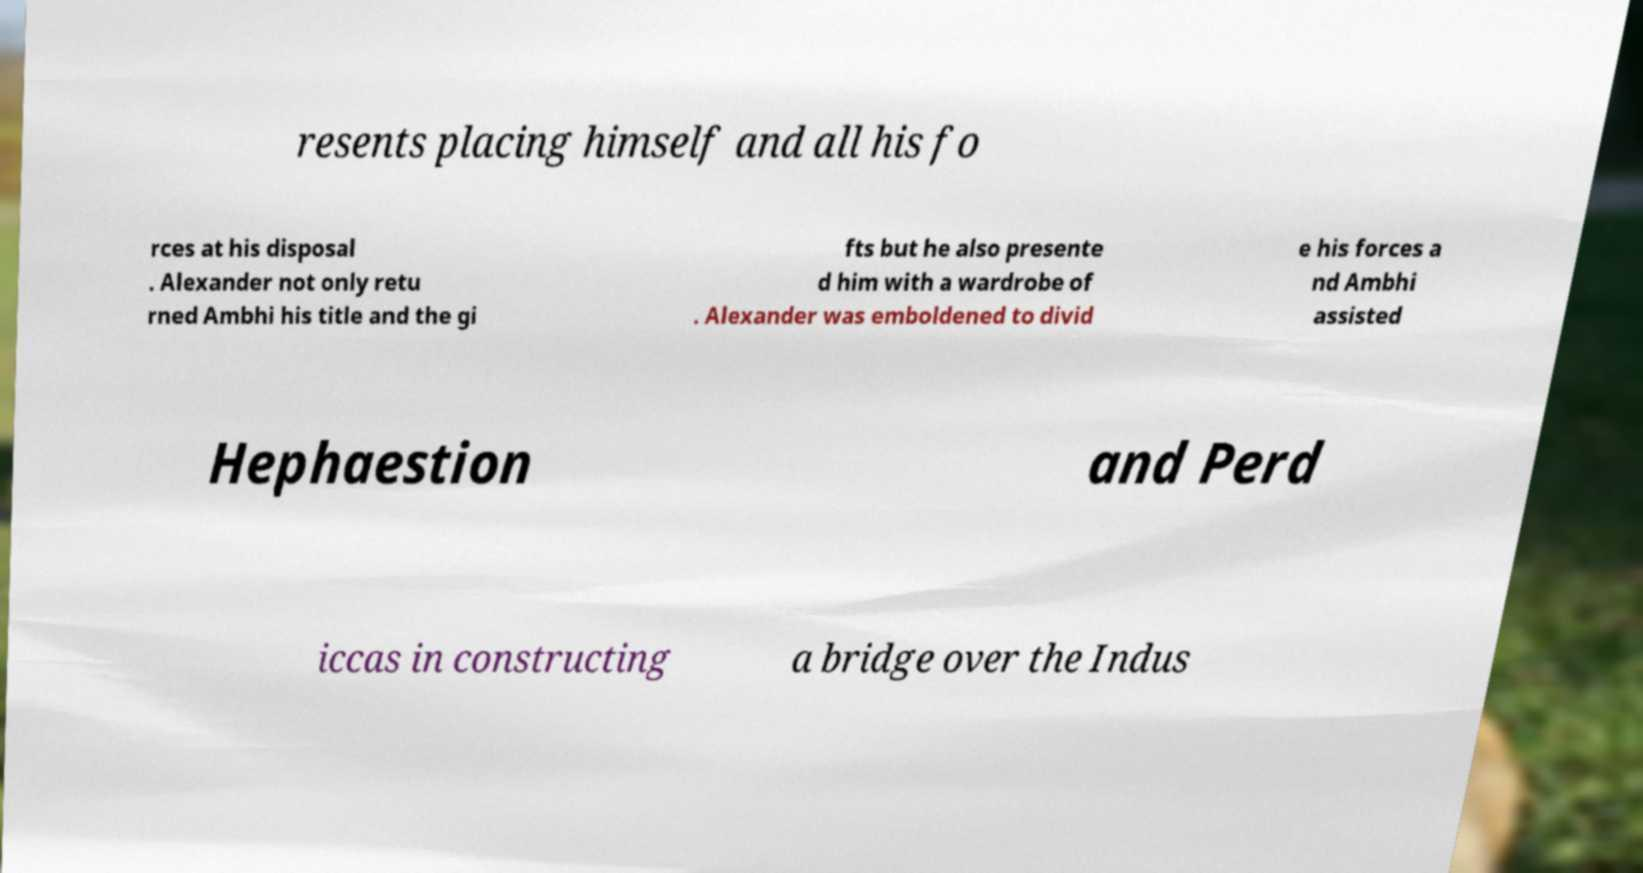Please read and relay the text visible in this image. What does it say? resents placing himself and all his fo rces at his disposal . Alexander not only retu rned Ambhi his title and the gi fts but he also presente d him with a wardrobe of . Alexander was emboldened to divid e his forces a nd Ambhi assisted Hephaestion and Perd iccas in constructing a bridge over the Indus 